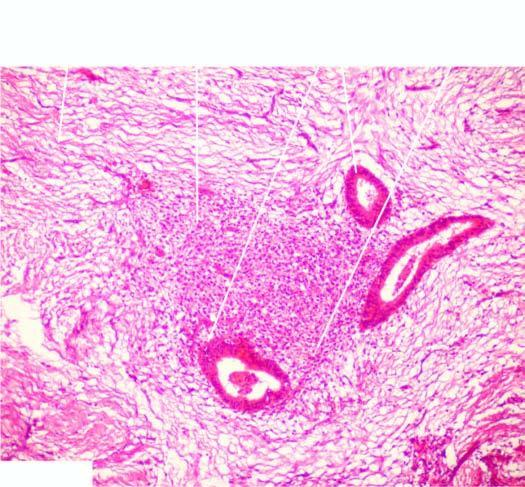what contains endometrial glands, stroma and evidence of preceding old haemorrhage?
Answer the question using a single word or phrase. Dense fibrocollagenic tissue 